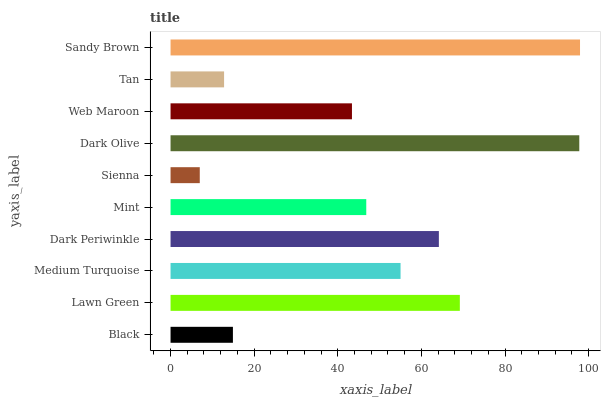Is Sienna the minimum?
Answer yes or no. Yes. Is Sandy Brown the maximum?
Answer yes or no. Yes. Is Lawn Green the minimum?
Answer yes or no. No. Is Lawn Green the maximum?
Answer yes or no. No. Is Lawn Green greater than Black?
Answer yes or no. Yes. Is Black less than Lawn Green?
Answer yes or no. Yes. Is Black greater than Lawn Green?
Answer yes or no. No. Is Lawn Green less than Black?
Answer yes or no. No. Is Medium Turquoise the high median?
Answer yes or no. Yes. Is Mint the low median?
Answer yes or no. Yes. Is Sienna the high median?
Answer yes or no. No. Is Sandy Brown the low median?
Answer yes or no. No. 